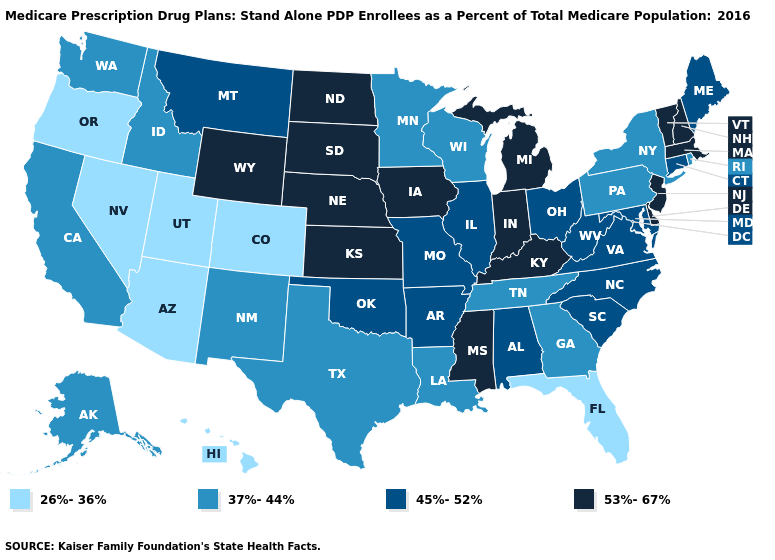Is the legend a continuous bar?
Answer briefly. No. What is the value of Massachusetts?
Write a very short answer. 53%-67%. Name the states that have a value in the range 53%-67%?
Concise answer only. Delaware, Iowa, Indiana, Kansas, Kentucky, Massachusetts, Michigan, Mississippi, North Dakota, Nebraska, New Hampshire, New Jersey, South Dakota, Vermont, Wyoming. What is the highest value in the MidWest ?
Be succinct. 53%-67%. What is the value of Connecticut?
Write a very short answer. 45%-52%. Name the states that have a value in the range 53%-67%?
Be succinct. Delaware, Iowa, Indiana, Kansas, Kentucky, Massachusetts, Michigan, Mississippi, North Dakota, Nebraska, New Hampshire, New Jersey, South Dakota, Vermont, Wyoming. What is the value of Oklahoma?
Give a very brief answer. 45%-52%. Does Hawaii have a lower value than Arizona?
Write a very short answer. No. Does Florida have the lowest value in the South?
Write a very short answer. Yes. Among the states that border Minnesota , does North Dakota have the highest value?
Short answer required. Yes. Which states hav the highest value in the West?
Quick response, please. Wyoming. Does Colorado have the same value as Utah?
Short answer required. Yes. What is the value of Wisconsin?
Answer briefly. 37%-44%. What is the value of South Dakota?
Give a very brief answer. 53%-67%. What is the value of Connecticut?
Quick response, please. 45%-52%. 